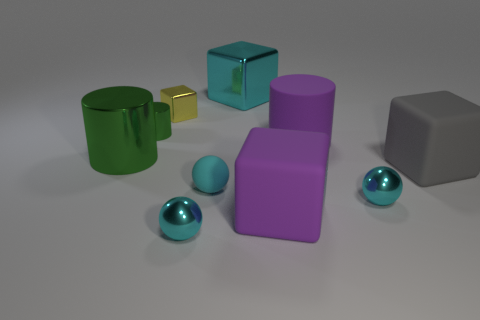Subtract all cyan metallic balls. How many balls are left? 1 Subtract 3 cylinders. How many cylinders are left? 0 Subtract all cyan cubes. How many cubes are left? 3 Add 9 cyan matte cylinders. How many cyan matte cylinders exist? 9 Subtract 1 cyan balls. How many objects are left? 9 Subtract all spheres. How many objects are left? 7 Subtract all brown balls. Subtract all blue blocks. How many balls are left? 3 Subtract all brown cylinders. How many yellow blocks are left? 1 Subtract all cyan metallic things. Subtract all large metal cylinders. How many objects are left? 6 Add 2 small cubes. How many small cubes are left? 3 